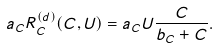<formula> <loc_0><loc_0><loc_500><loc_500>a _ { C } R _ { C } ^ { ( d ) } ( C , U ) = a _ { C } U \frac { C } { b _ { C } + C } .</formula> 